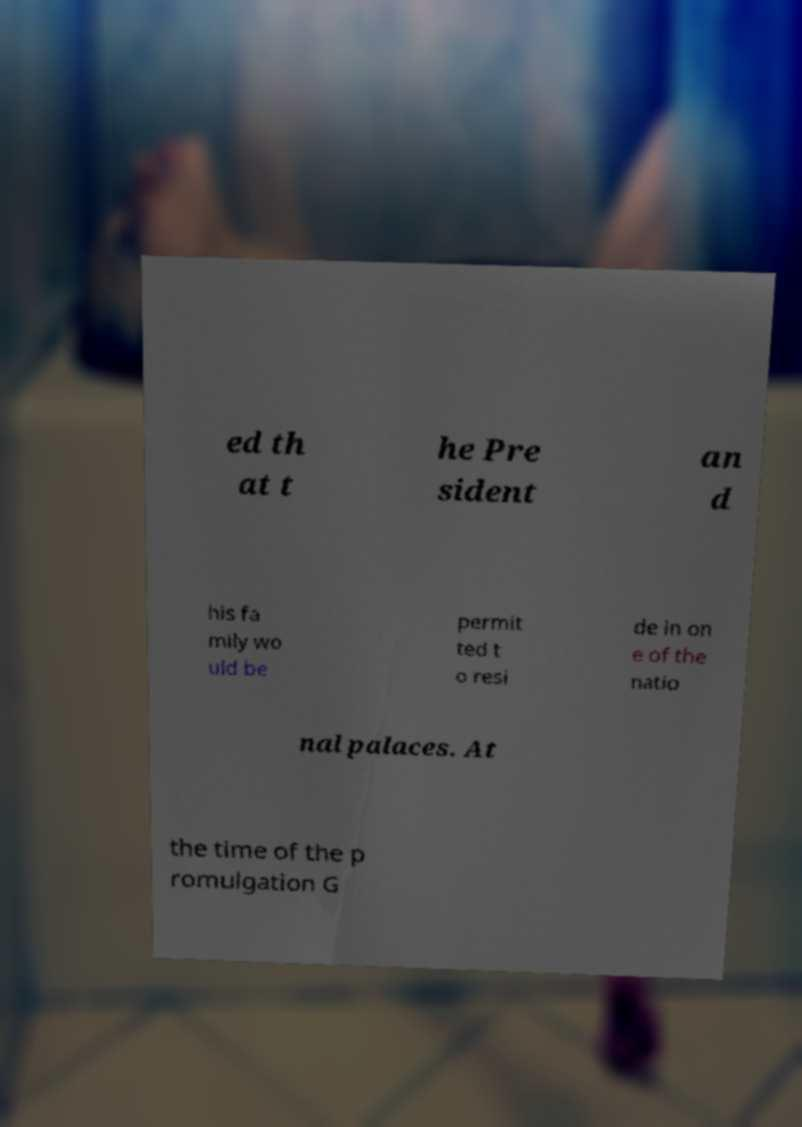I need the written content from this picture converted into text. Can you do that? ed th at t he Pre sident an d his fa mily wo uld be permit ted t o resi de in on e of the natio nal palaces. At the time of the p romulgation G 